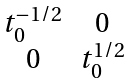<formula> <loc_0><loc_0><loc_500><loc_500>\begin{matrix} t _ { 0 } ^ { - 1 / 2 } & 0 \\ 0 & t _ { 0 } ^ { 1 / 2 } \end{matrix}</formula> 